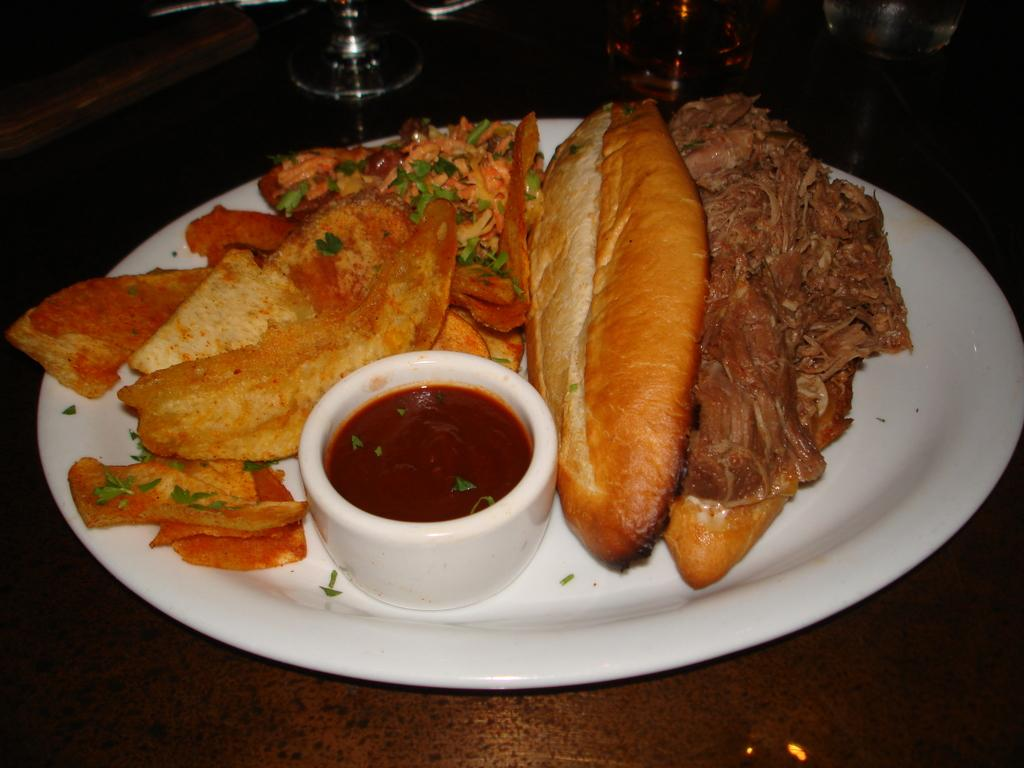What is on the plate that is visible in the image? There is a plate filled with food items in the image. Are there any other containers or dishes in the image besides the plate? Yes, there is a small bowl in the image. What type of jewel is being protested against in the image? There is no reference to a jewel or protest in the image; it features a plate filled with food items and a small bowl. 